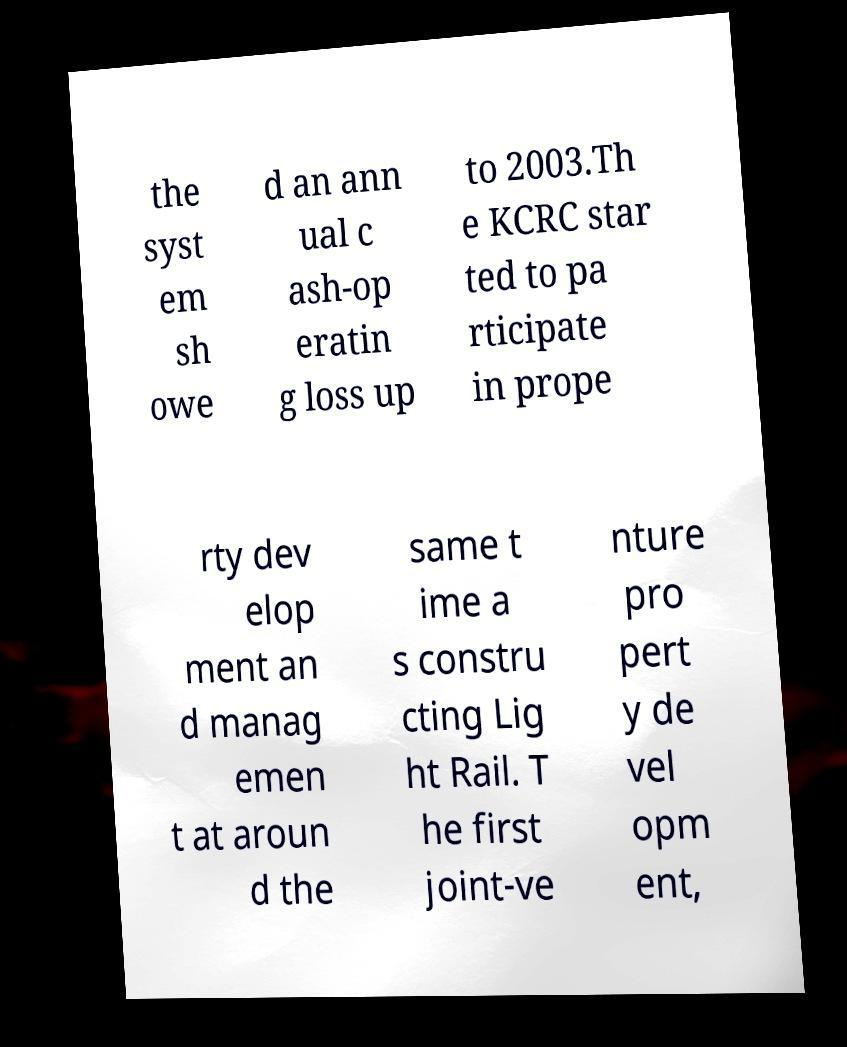Can you read and provide the text displayed in the image?This photo seems to have some interesting text. Can you extract and type it out for me? the syst em sh owe d an ann ual c ash-op eratin g loss up to 2003.Th e KCRC star ted to pa rticipate in prope rty dev elop ment an d manag emen t at aroun d the same t ime a s constru cting Lig ht Rail. T he first joint-ve nture pro pert y de vel opm ent, 